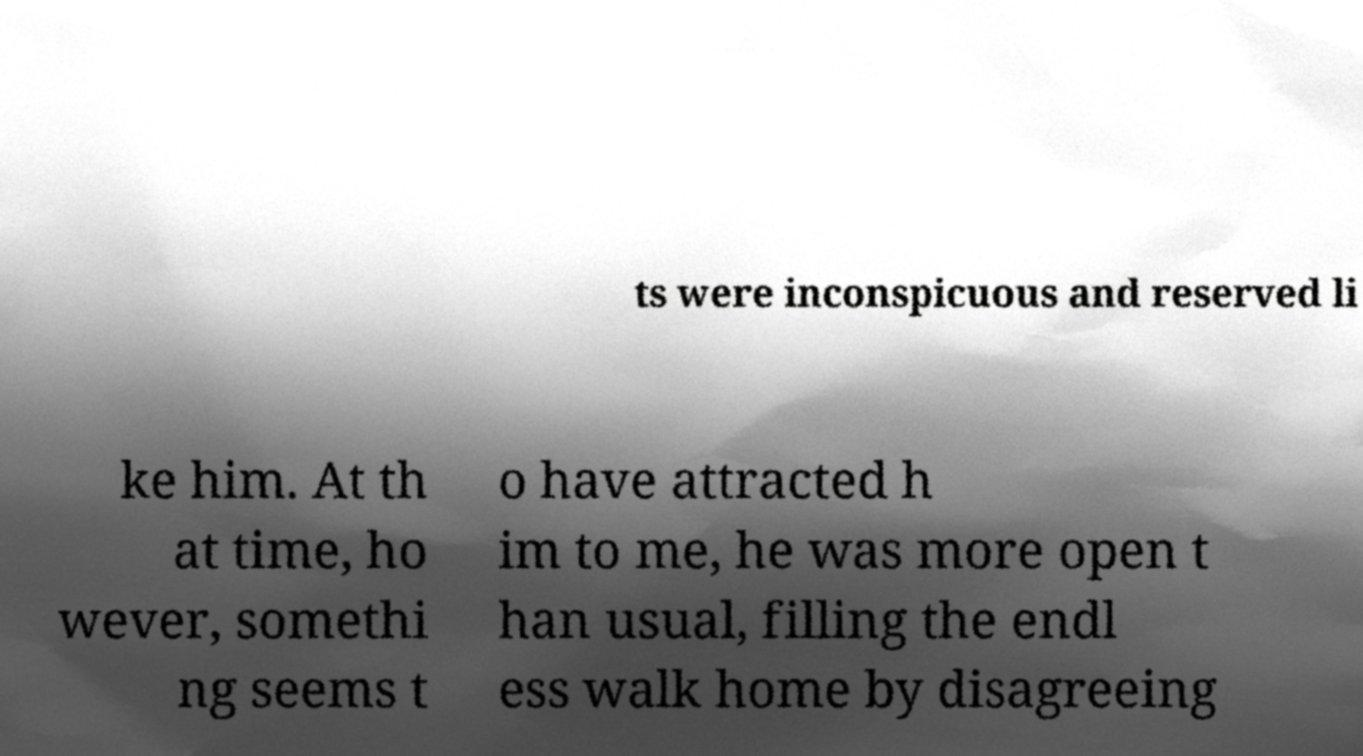Could you assist in decoding the text presented in this image and type it out clearly? ts were inconspicuous and reserved li ke him. At th at time, ho wever, somethi ng seems t o have attracted h im to me, he was more open t han usual, filling the endl ess walk home by disagreeing 